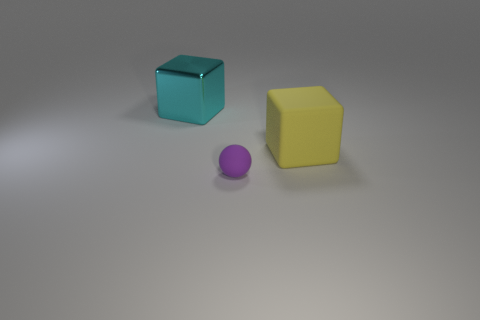What could be the function of these objects in real life? In real life, objects of these shapes could serve various functions. The cube could be a die for board games or a decorative item. The sphere could be a small ball used for playing or as a part of a larger mechanism. The context and scale of these objects would better define their specific functions. 